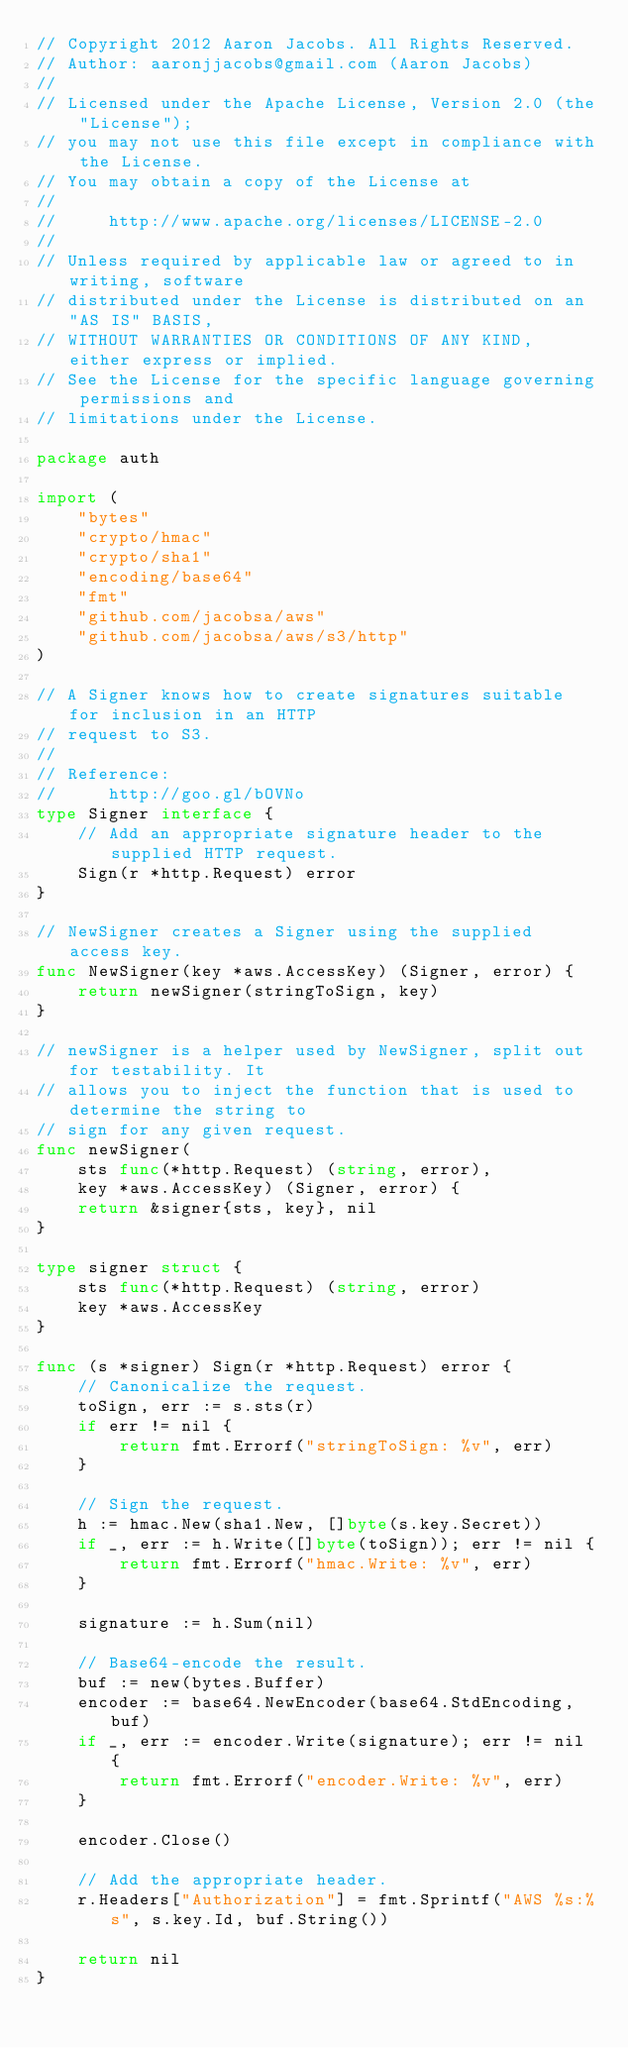Convert code to text. <code><loc_0><loc_0><loc_500><loc_500><_Go_>// Copyright 2012 Aaron Jacobs. All Rights Reserved.
// Author: aaronjjacobs@gmail.com (Aaron Jacobs)
//
// Licensed under the Apache License, Version 2.0 (the "License");
// you may not use this file except in compliance with the License.
// You may obtain a copy of the License at
//
//     http://www.apache.org/licenses/LICENSE-2.0
//
// Unless required by applicable law or agreed to in writing, software
// distributed under the License is distributed on an "AS IS" BASIS,
// WITHOUT WARRANTIES OR CONDITIONS OF ANY KIND, either express or implied.
// See the License for the specific language governing permissions and
// limitations under the License.

package auth

import (
	"bytes"
	"crypto/hmac"
	"crypto/sha1"
	"encoding/base64"
	"fmt"
	"github.com/jacobsa/aws"
	"github.com/jacobsa/aws/s3/http"
)

// A Signer knows how to create signatures suitable for inclusion in an HTTP
// request to S3.
//
// Reference:
//     http://goo.gl/bOVNo
type Signer interface {
	// Add an appropriate signature header to the supplied HTTP request.
	Sign(r *http.Request) error
}

// NewSigner creates a Signer using the supplied access key.
func NewSigner(key *aws.AccessKey) (Signer, error) {
	return newSigner(stringToSign, key)
}

// newSigner is a helper used by NewSigner, split out for testability. It
// allows you to inject the function that is used to determine the string to
// sign for any given request.
func newSigner(
	sts func(*http.Request) (string, error),
	key *aws.AccessKey) (Signer, error) {
	return &signer{sts, key}, nil
}

type signer struct {
	sts func(*http.Request) (string, error)
	key *aws.AccessKey
}

func (s *signer) Sign(r *http.Request) error {
	// Canonicalize the request.
	toSign, err := s.sts(r)
	if err != nil {
		return fmt.Errorf("stringToSign: %v", err)
	}

	// Sign the request.
	h := hmac.New(sha1.New, []byte(s.key.Secret))
	if _, err := h.Write([]byte(toSign)); err != nil {
		return fmt.Errorf("hmac.Write: %v", err)
	}

	signature := h.Sum(nil)

	// Base64-encode the result.
	buf := new(bytes.Buffer)
	encoder := base64.NewEncoder(base64.StdEncoding, buf)
	if _, err := encoder.Write(signature); err != nil {
		return fmt.Errorf("encoder.Write: %v", err)
	}

	encoder.Close()

	// Add the appropriate header.
	r.Headers["Authorization"] = fmt.Sprintf("AWS %s:%s", s.key.Id, buf.String())

	return nil
}
</code> 